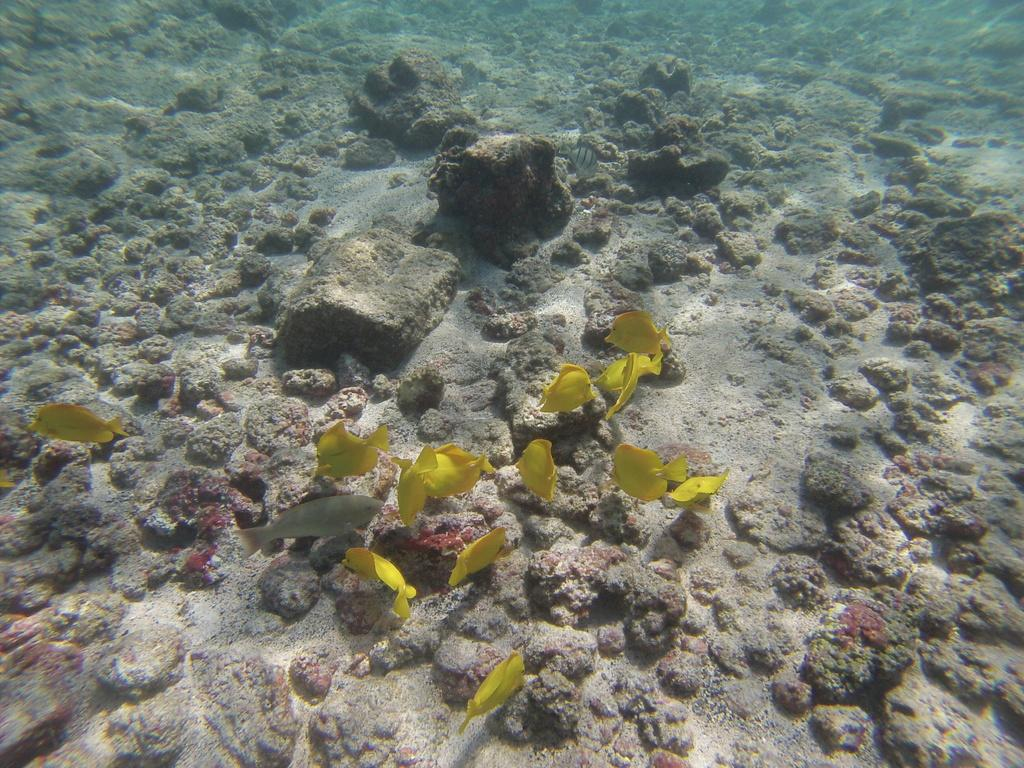What is the main subject of the image? The image depicts a water body. What can be found in the water body? There are fishes in the water body. Are there any other objects or features visible in the image? Yes, there are rocks present in the image. How many sticks can be seen floating in the water body? There are no sticks visible in the image; it only shows a water body with fishes and rocks. 